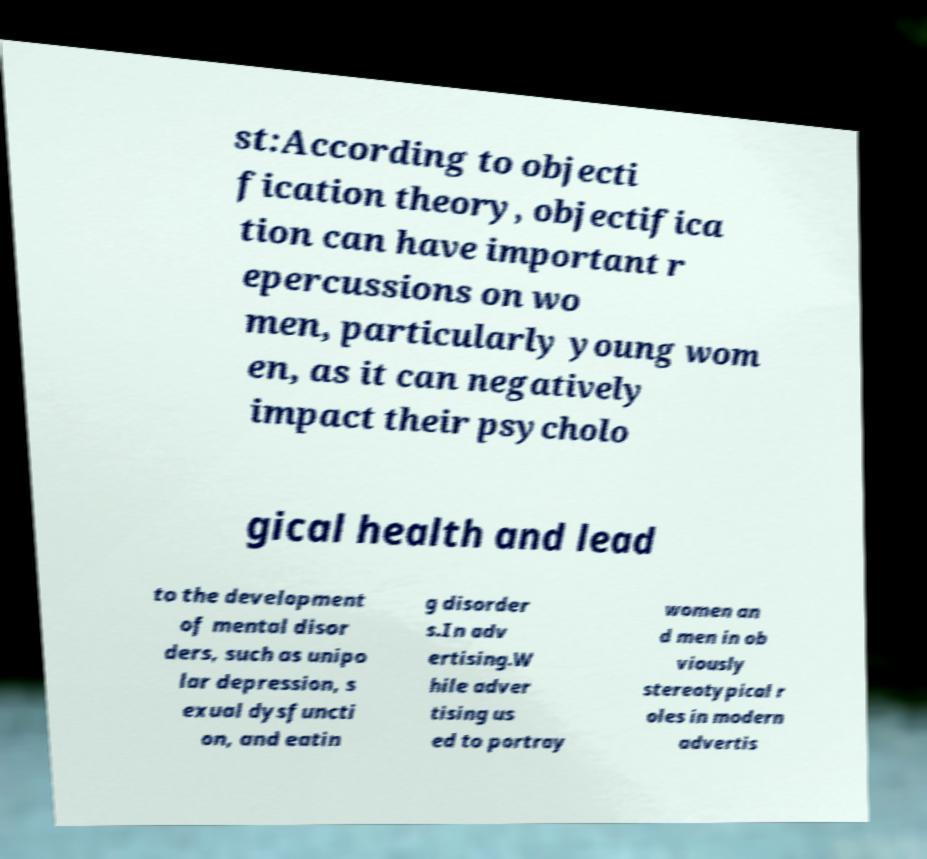Can you accurately transcribe the text from the provided image for me? st:According to objecti fication theory, objectifica tion can have important r epercussions on wo men, particularly young wom en, as it can negatively impact their psycholo gical health and lead to the development of mental disor ders, such as unipo lar depression, s exual dysfuncti on, and eatin g disorder s.In adv ertising.W hile adver tising us ed to portray women an d men in ob viously stereotypical r oles in modern advertis 